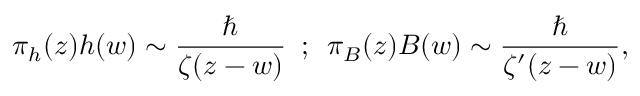Convert formula to latex. <formula><loc_0><loc_0><loc_500><loc_500>\pi _ { h } ( z ) h ( w ) \sim { \frac { } { \zeta ( z - w ) } } \, ; \, \pi _ { B } ( z ) B ( w ) \sim { \frac { } { \zeta ^ { \prime } ( z - w ) } } ,</formula> 